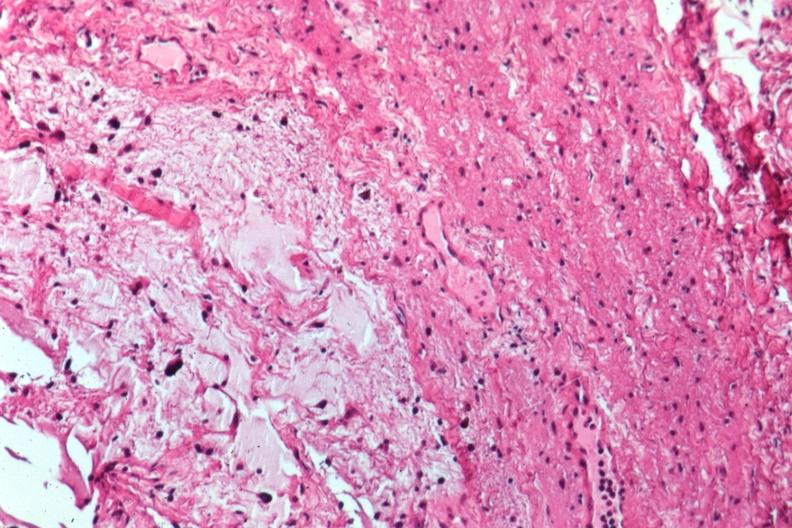what is present?
Answer the question using a single word or phrase. Optic nerve 